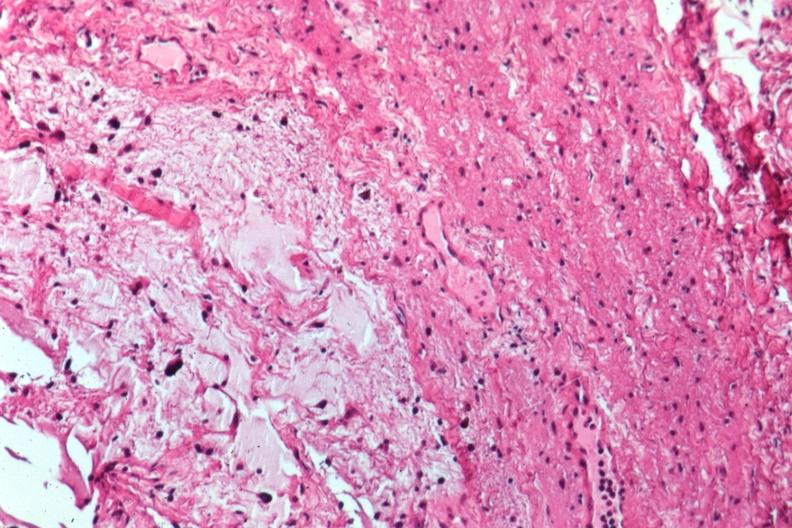what is present?
Answer the question using a single word or phrase. Optic nerve 